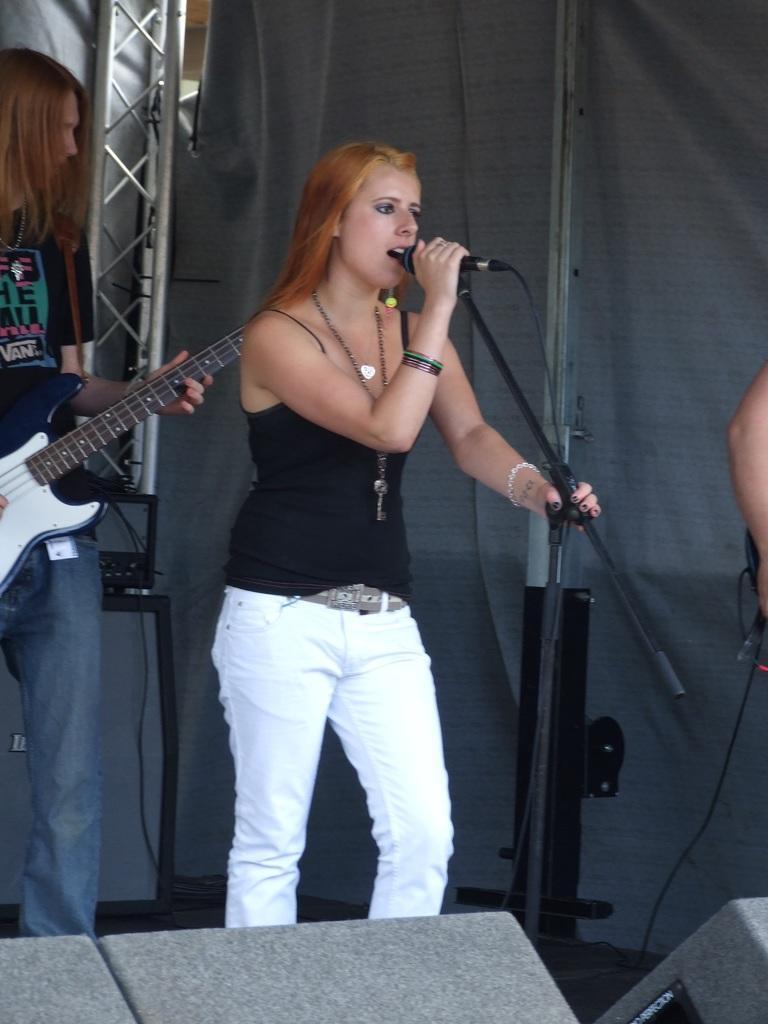Please provide a concise description of this image. In this image their is a woman who is standing and singing through the mic which is in front of her. At the background there is another woman who is playing the guitar with her hand. There is a cloth to the right side. 